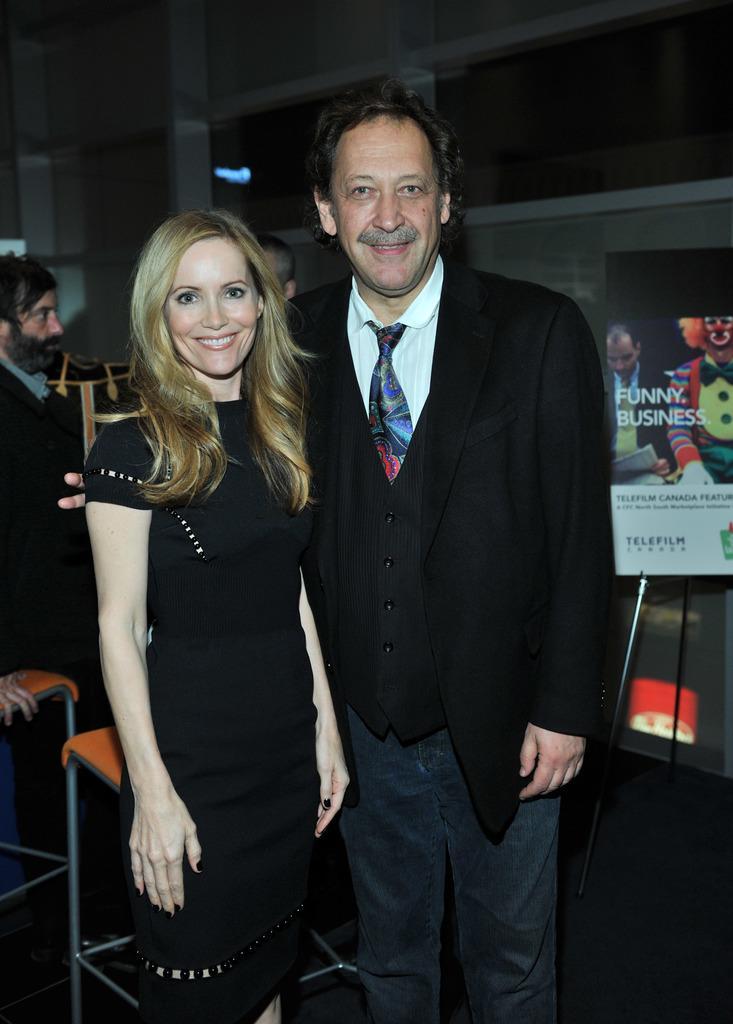How would you summarize this image in a sentence or two? In the image there is a man with black suit and white shirt standing beside a woman in black dress, she had blond hair, on the right side there is a banner behind them there are few persons standing, this seems to be clicked inside a building. 